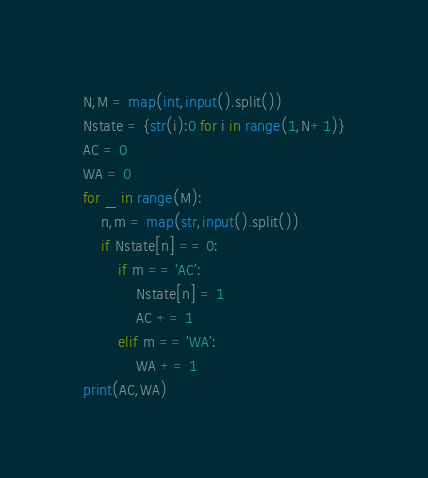<code> <loc_0><loc_0><loc_500><loc_500><_Python_>N,M = map(int,input().split())
Nstate = {str(i):0 for i in range(1,N+1)}
AC = 0
WA = 0
for _ in range(M):
    n,m = map(str,input().split())
    if Nstate[n] == 0:
        if m == 'AC':
            Nstate[n] = 1
            AC += 1
        elif m == 'WA':
            WA += 1
print(AC,WA)</code> 